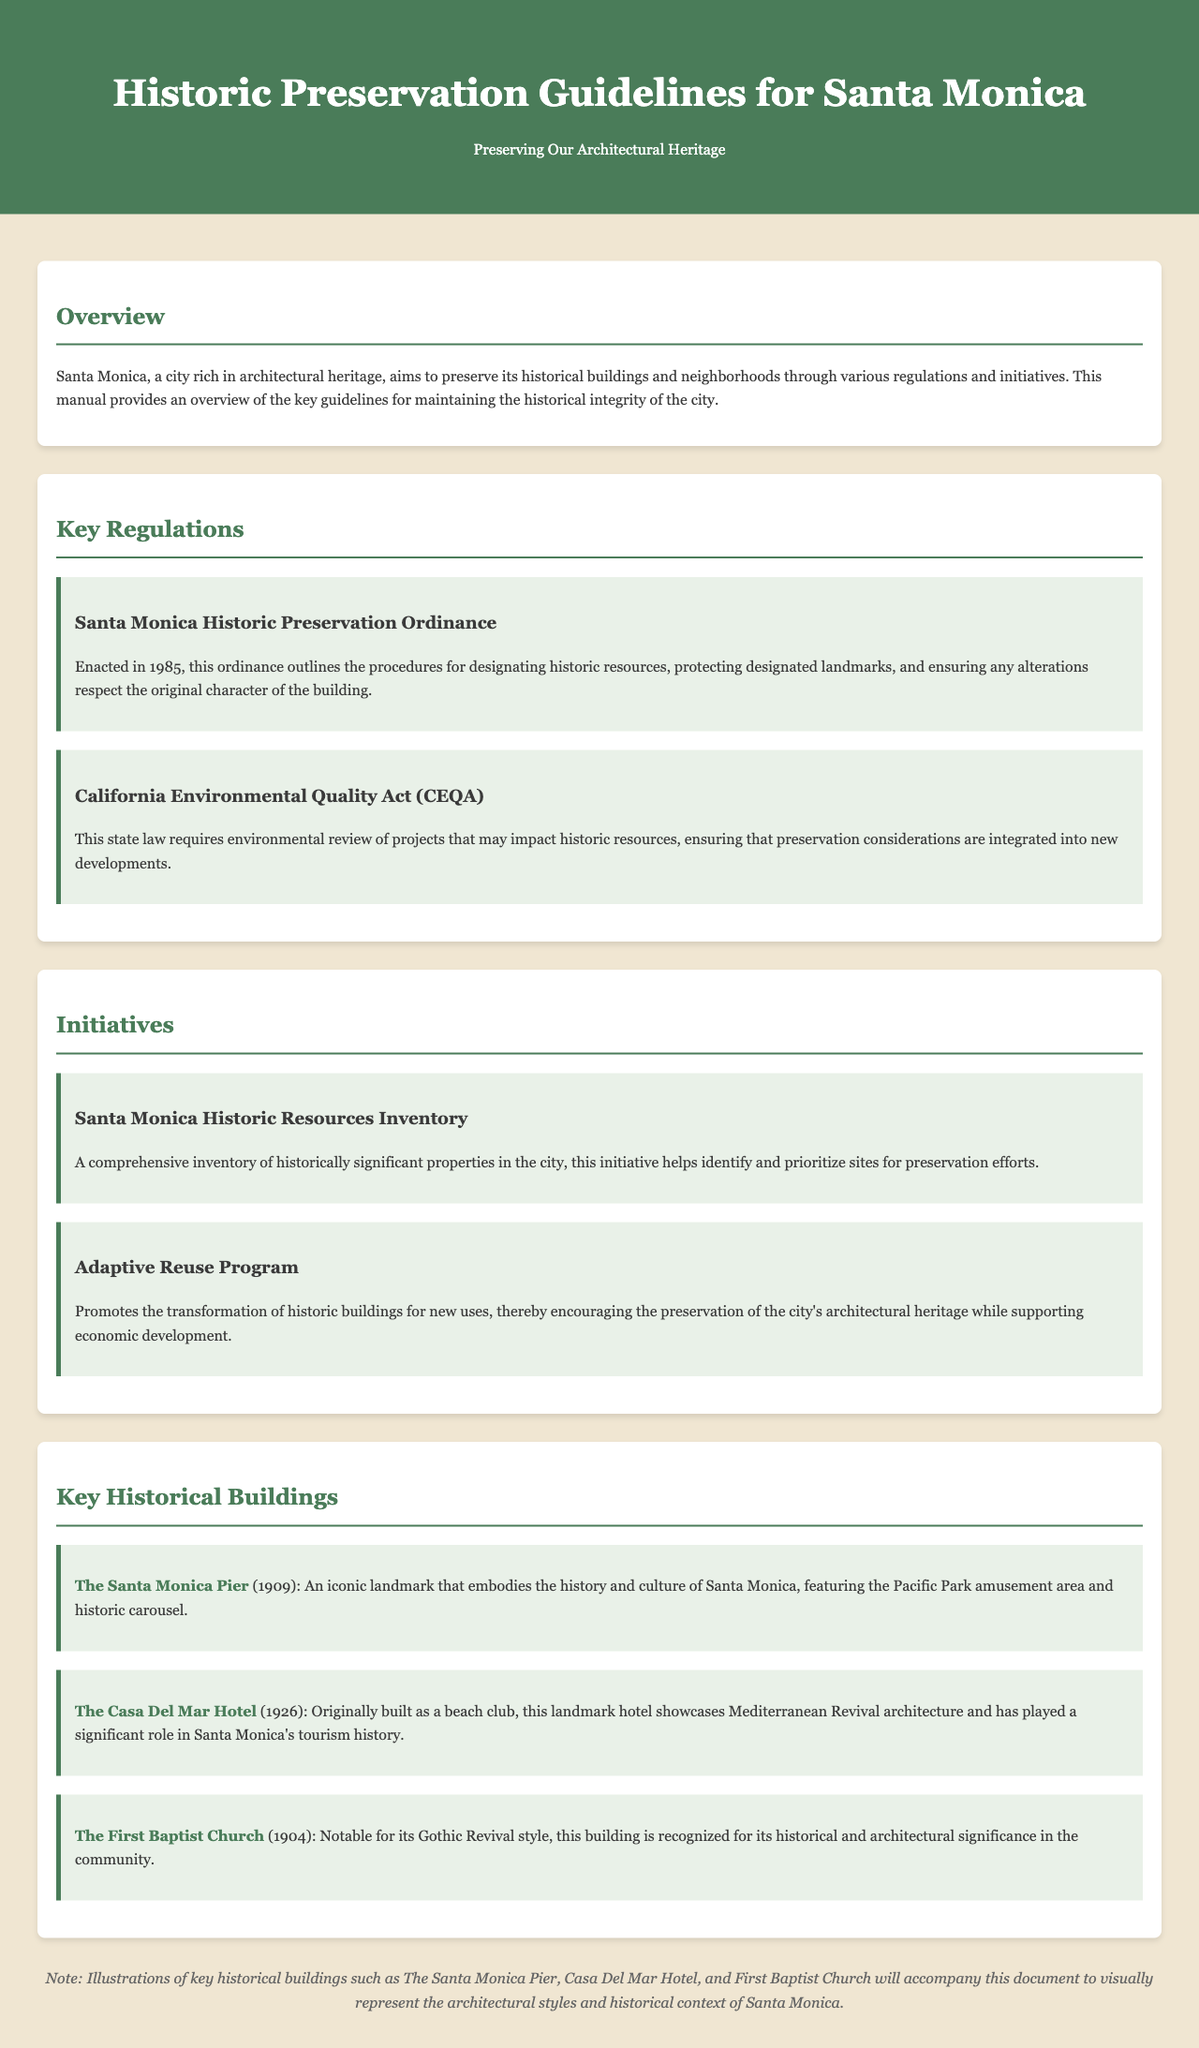What year was the Santa Monica Historic Preservation Ordinance enacted? The document states that the Santa Monica Historic Preservation Ordinance was enacted in 1985.
Answer: 1985 What is the main focus of the California Environmental Quality Act (CEQA)? The CEQA is aimed at requiring environmental review of projects that may impact historic resources.
Answer: Environmental review What initiative catalogs historically significant properties in Santa Monica? The document refers to the Santa Monica Historic Resources Inventory as the initiative that catalogs these properties.
Answer: Santa Monica Historic Resources Inventory Which building in Santa Monica was originally built as a beach club? The Casa Del Mar Hotel is noted for having originally been built as a beach club.
Answer: Casa Del Mar Hotel What style is The First Baptist Church recognized for? The First Baptist Church is noted for its Gothic Revival style.
Answer: Gothic Revival Name an aspect that the Adaptive Reuse Program encourages. The Adaptive Reuse Program encourages the preservation of the city's architectural heritage.
Answer: Preservation What is the publication's primary purpose? The manual's primary purpose is to provide an overview of key guidelines for maintaining the historical integrity of Santa Monica.
Answer: Overview of guidelines What architectural feature does the Santa Monica Pier include? The Santa Monica Pier features the Pacific Park amusement area and a historic carousel.
Answer: Historic carousel What architectural style does the Casa Del Mar Hotel showcase? The Casa Del Mar Hotel showcases Mediterranean Revival architecture.
Answer: Mediterranean Revival 